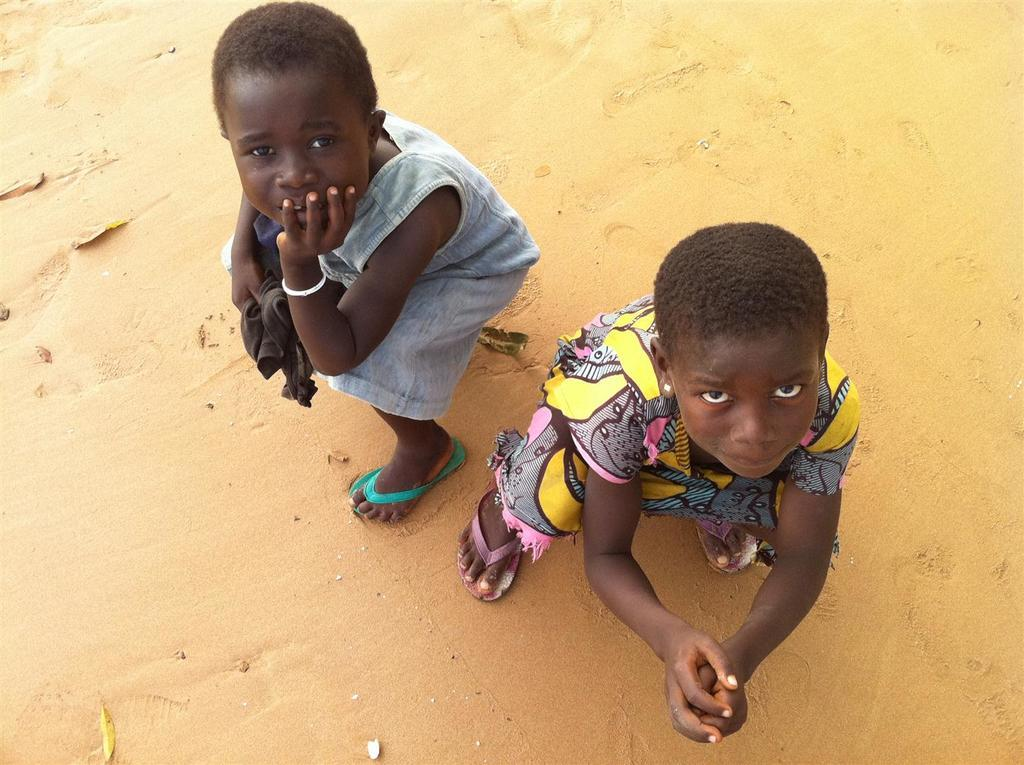How many kids are in the image? There are two kids in the image. Where are the kids located? The kids are on the land. What is one of the kids holding? One of the kids is holding a cloth. What is the tax rate on the island depicted in the image? There is no island or tax rate mentioned in the image; it simply shows two kids on the land. 